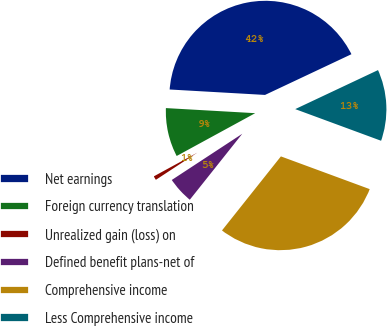<chart> <loc_0><loc_0><loc_500><loc_500><pie_chart><fcel>Net earnings<fcel>Foreign currency translation<fcel>Unrealized gain (loss) on<fcel>Defined benefit plans-net of<fcel>Comprehensive income<fcel>Less Comprehensive income<nl><fcel>42.08%<fcel>8.85%<fcel>1.29%<fcel>5.07%<fcel>30.07%<fcel>12.63%<nl></chart> 